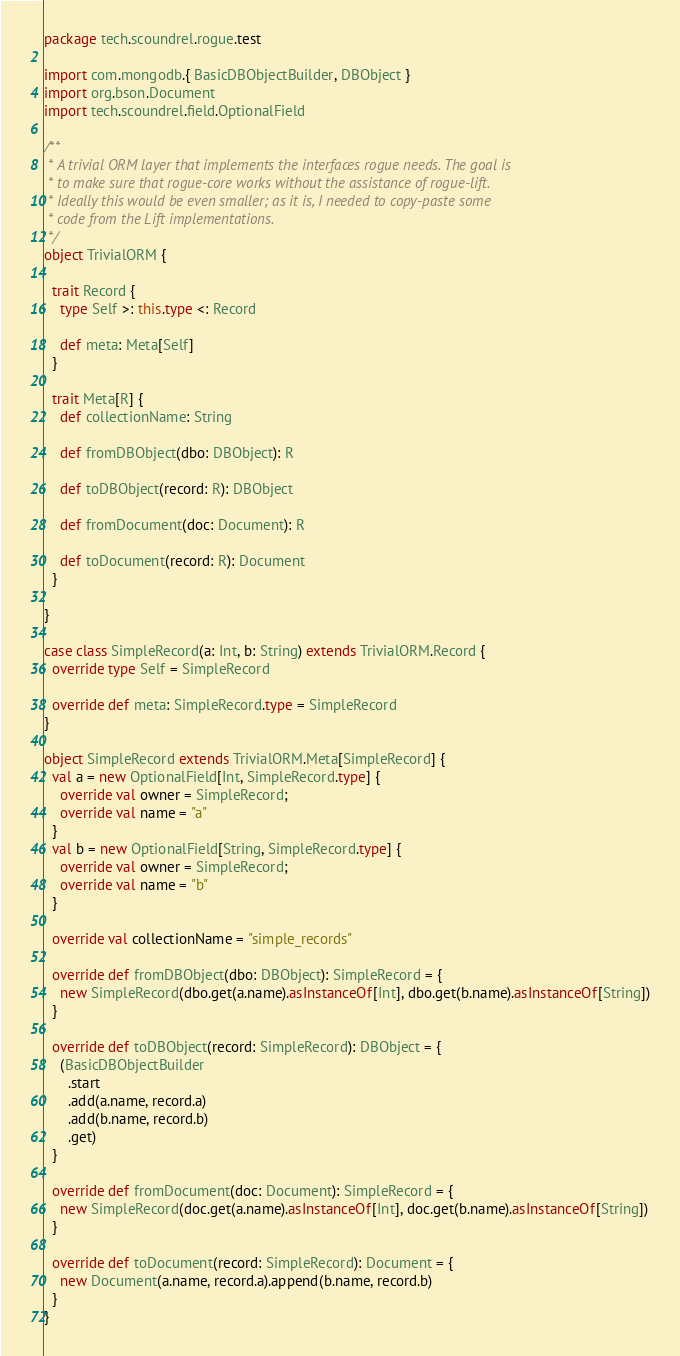<code> <loc_0><loc_0><loc_500><loc_500><_Scala_>package tech.scoundrel.rogue.test

import com.mongodb.{ BasicDBObjectBuilder, DBObject }
import org.bson.Document
import tech.scoundrel.field.OptionalField

/**
 * A trivial ORM layer that implements the interfaces rogue needs. The goal is
 * to make sure that rogue-core works without the assistance of rogue-lift.
 * Ideally this would be even smaller; as it is, I needed to copy-paste some
 * code from the Lift implementations.
 */
object TrivialORM {

  trait Record {
    type Self >: this.type <: Record

    def meta: Meta[Self]
  }

  trait Meta[R] {
    def collectionName: String

    def fromDBObject(dbo: DBObject): R

    def toDBObject(record: R): DBObject

    def fromDocument(doc: Document): R

    def toDocument(record: R): Document
  }

}

case class SimpleRecord(a: Int, b: String) extends TrivialORM.Record {
  override type Self = SimpleRecord

  override def meta: SimpleRecord.type = SimpleRecord
}

object SimpleRecord extends TrivialORM.Meta[SimpleRecord] {
  val a = new OptionalField[Int, SimpleRecord.type] {
    override val owner = SimpleRecord;
    override val name = "a"
  }
  val b = new OptionalField[String, SimpleRecord.type] {
    override val owner = SimpleRecord;
    override val name = "b"
  }

  override val collectionName = "simple_records"

  override def fromDBObject(dbo: DBObject): SimpleRecord = {
    new SimpleRecord(dbo.get(a.name).asInstanceOf[Int], dbo.get(b.name).asInstanceOf[String])
  }

  override def toDBObject(record: SimpleRecord): DBObject = {
    (BasicDBObjectBuilder
      .start
      .add(a.name, record.a)
      .add(b.name, record.b)
      .get)
  }

  override def fromDocument(doc: Document): SimpleRecord = {
    new SimpleRecord(doc.get(a.name).asInstanceOf[Int], doc.get(b.name).asInstanceOf[String])
  }

  override def toDocument(record: SimpleRecord): Document = {
    new Document(a.name, record.a).append(b.name, record.b)
  }
}</code> 